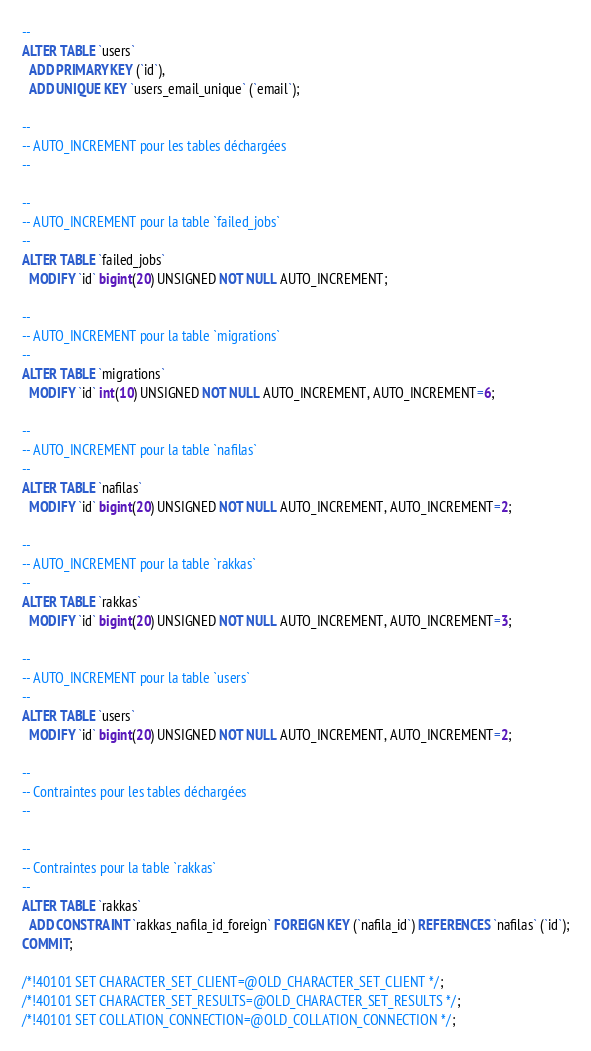Convert code to text. <code><loc_0><loc_0><loc_500><loc_500><_SQL_>--
ALTER TABLE `users`
  ADD PRIMARY KEY (`id`),
  ADD UNIQUE KEY `users_email_unique` (`email`);

--
-- AUTO_INCREMENT pour les tables déchargées
--

--
-- AUTO_INCREMENT pour la table `failed_jobs`
--
ALTER TABLE `failed_jobs`
  MODIFY `id` bigint(20) UNSIGNED NOT NULL AUTO_INCREMENT;

--
-- AUTO_INCREMENT pour la table `migrations`
--
ALTER TABLE `migrations`
  MODIFY `id` int(10) UNSIGNED NOT NULL AUTO_INCREMENT, AUTO_INCREMENT=6;

--
-- AUTO_INCREMENT pour la table `nafilas`
--
ALTER TABLE `nafilas`
  MODIFY `id` bigint(20) UNSIGNED NOT NULL AUTO_INCREMENT, AUTO_INCREMENT=2;

--
-- AUTO_INCREMENT pour la table `rakkas`
--
ALTER TABLE `rakkas`
  MODIFY `id` bigint(20) UNSIGNED NOT NULL AUTO_INCREMENT, AUTO_INCREMENT=3;

--
-- AUTO_INCREMENT pour la table `users`
--
ALTER TABLE `users`
  MODIFY `id` bigint(20) UNSIGNED NOT NULL AUTO_INCREMENT, AUTO_INCREMENT=2;

--
-- Contraintes pour les tables déchargées
--

--
-- Contraintes pour la table `rakkas`
--
ALTER TABLE `rakkas`
  ADD CONSTRAINT `rakkas_nafila_id_foreign` FOREIGN KEY (`nafila_id`) REFERENCES `nafilas` (`id`);
COMMIT;

/*!40101 SET CHARACTER_SET_CLIENT=@OLD_CHARACTER_SET_CLIENT */;
/*!40101 SET CHARACTER_SET_RESULTS=@OLD_CHARACTER_SET_RESULTS */;
/*!40101 SET COLLATION_CONNECTION=@OLD_COLLATION_CONNECTION */;
</code> 